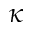<formula> <loc_0><loc_0><loc_500><loc_500>\kappa</formula> 